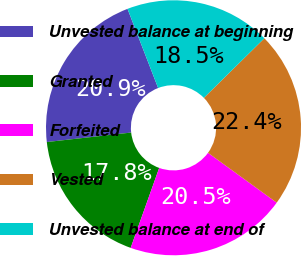Convert chart. <chart><loc_0><loc_0><loc_500><loc_500><pie_chart><fcel>Unvested balance at beginning<fcel>Granted<fcel>Forfeited<fcel>Vested<fcel>Unvested balance at end of<nl><fcel>20.91%<fcel>17.76%<fcel>20.46%<fcel>22.37%<fcel>18.49%<nl></chart> 